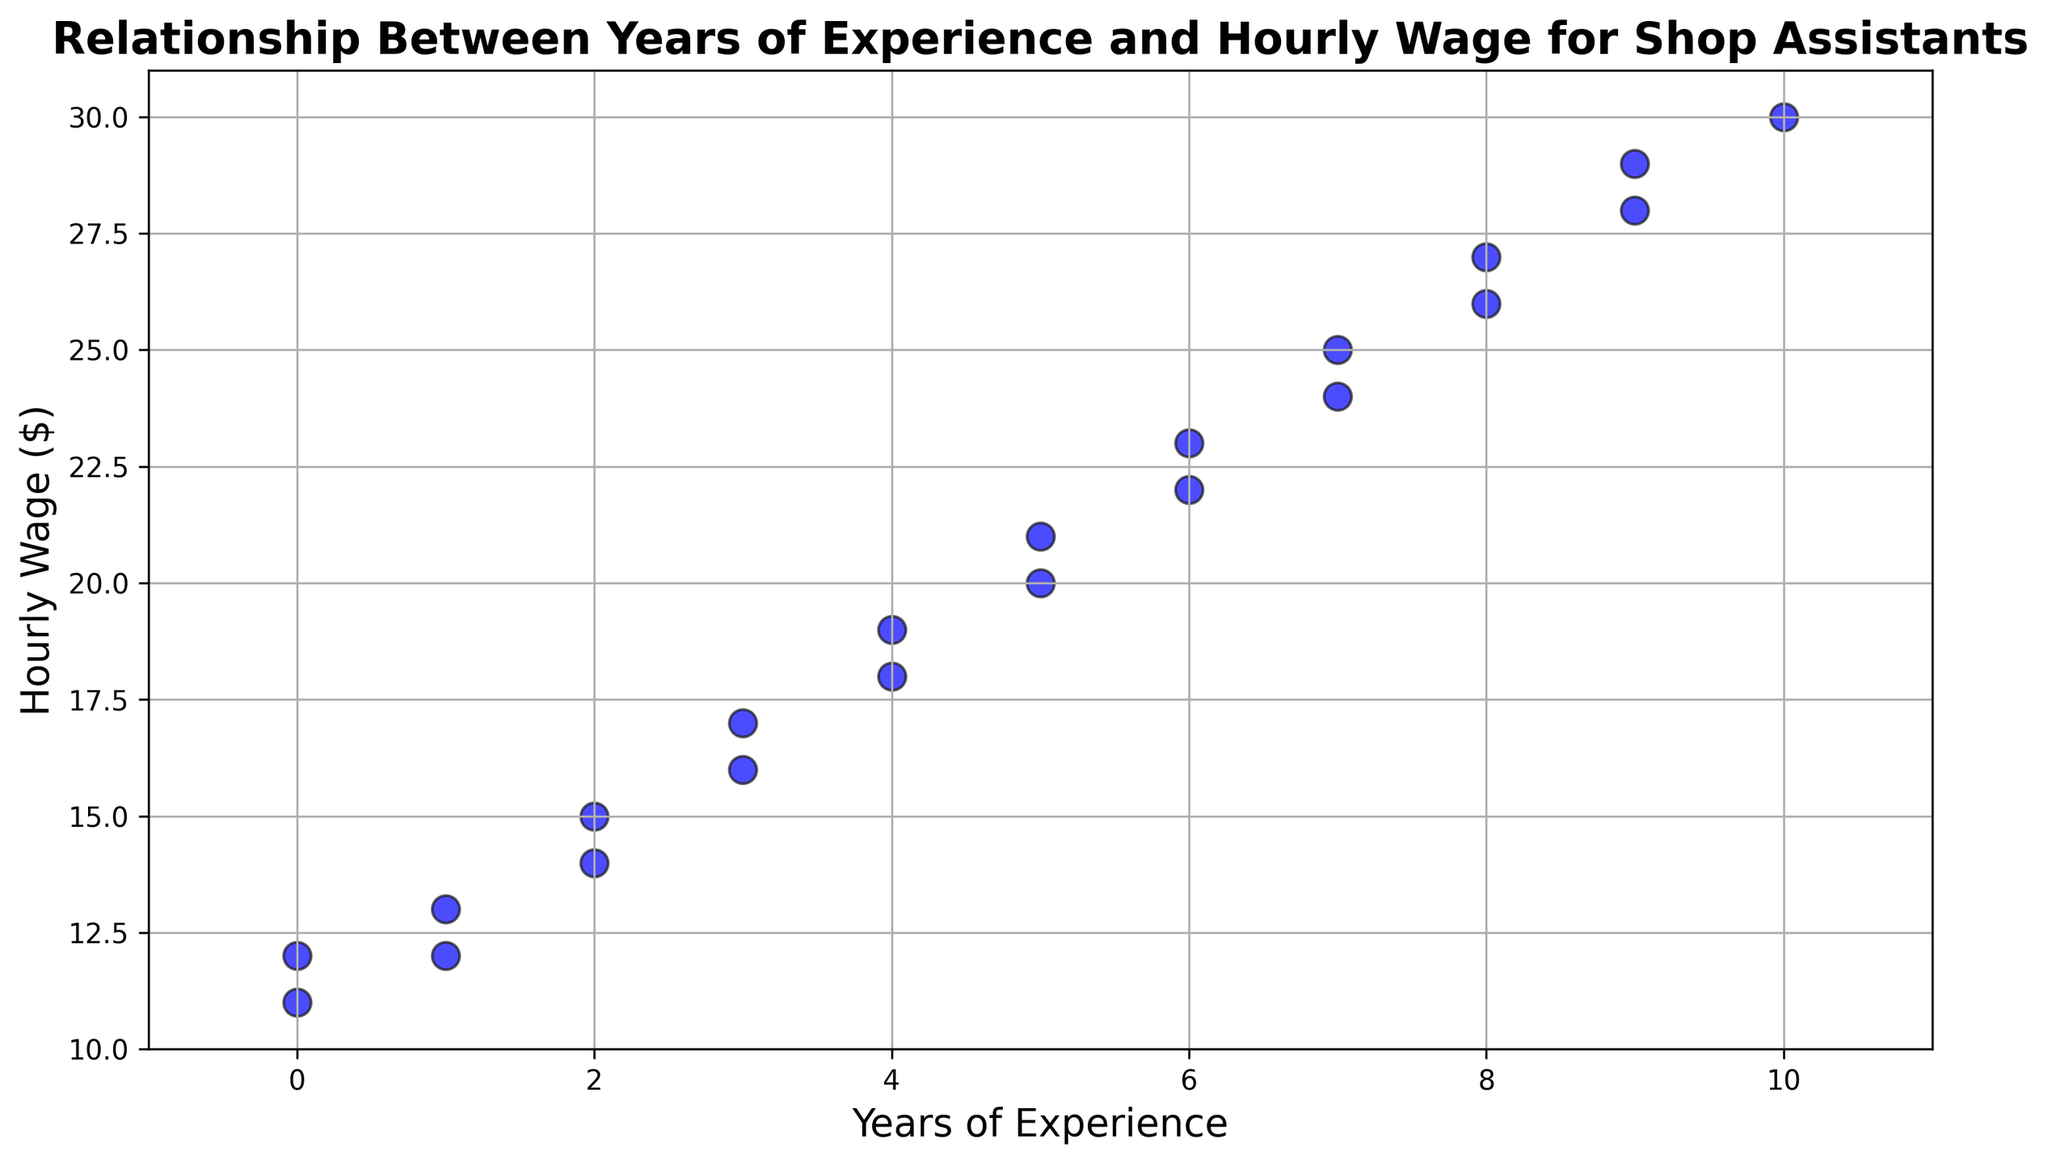What is the hourly wage of a shop assistant with 4 years of experience? Look at the data points where the 'Years_of_Experience' is 4 and identify the corresponding 'Hourly_Wage'. The points at 4 years experience have hourly wages of 18 and 19 dollars.
Answer: 18 or 19 Which hourly wage values are associated with 0 years of experience? Look at the data points where the 'Years_of_Experience' is 0 and identify the corresponding 'Hourly_Wage'. The points at 0 years experience have hourly wages of 11 and 12 dollars.
Answer: 11 and 12 What is the average hourly wage for shop assistants with 3, 4, and 5 years of experience? Sum the hourly wage values for 3 (16 and 17), 4 (18 and 19), and 5 (20 and 21) years of experience, and then divide by the number of data points (6). The sum is 16+17+18+19+20+21 = 111. The number of data points is 6, so the average is 111/6 = 18.5.
Answer: 18.5 How does the hourly wage change as years of experience increase from 1 to 2 years? Compare the hourly wage values for 1 year of experience (12 and 13) and 2 years of experience (14 and 15). The hourly wage increases from 12-13 to 14-15, which means an increase of 2 dollars.
Answer: Increases by 2 dollars What is the range of hourly wages for shop assistants with 6 years of experience? Identify the hourly wage values for 6 years of experience, which are 22 and 23. The range is the difference between the maximum and minimum values, i.e., 23 - 22 = 1.
Answer: 1 What is the highest hourly wage observed in the plot? Look at all the hourly wage values in the plot and identify the maximum one, which is 30 dollars.
Answer: 30 For which years of experience are the hourly wages $20 and $21? Look at the data points where the 'Hourly_Wage' is 20 and 21, and identify the corresponding 'Years_of_Experience'. Both hourly wages are associated with 5 years of experience.
Answer: 5 years Do shop assistants with 10 years of experience have higher hourly wages than those with 9 years of experience? Compare the hourly wage values for 9 (28 and 29) and 10 (30) years of experience. The hourly wage for 10 years is higher than those for 9 years.
Answer: Yes 